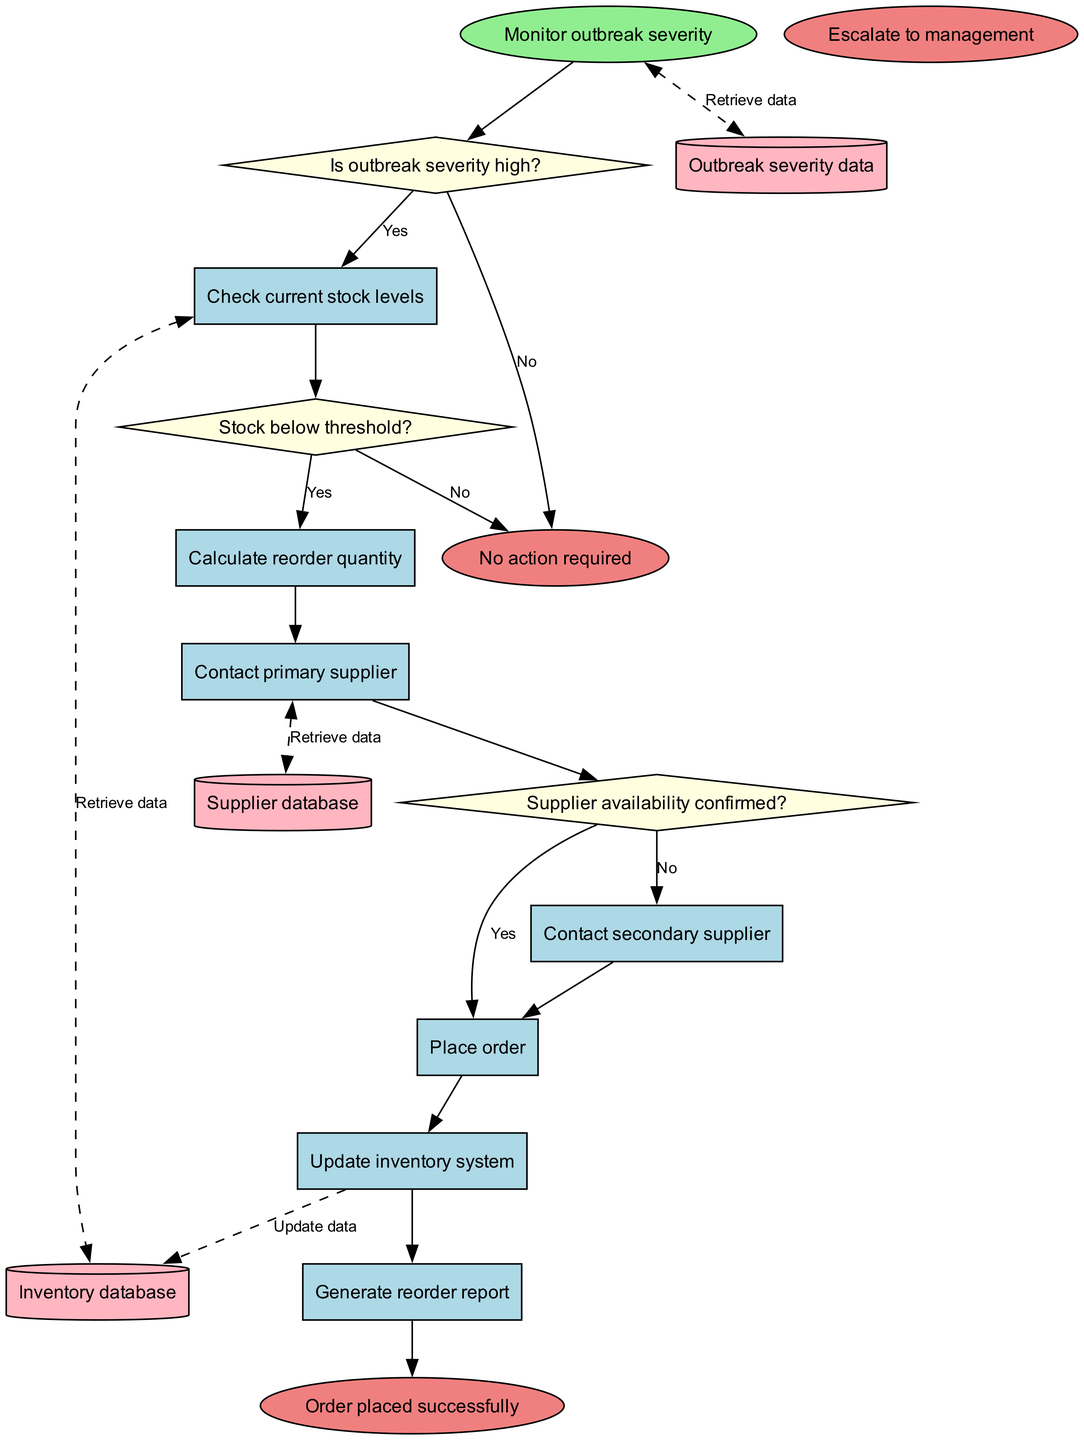What is the starting node of the process? The starting node, which represents the beginning of the flowchart, is labeled "Monitor outbreak severity."
Answer: Monitor outbreak severity How many decision nodes are present in the flowchart? The flowchart contains three decision nodes: "Is outbreak severity high?", "Stock below threshold?", and "Supplier availability confirmed?"
Answer: Three What happens when the outbreak severity is not high? If the outbreak severity is not high, the flowchart indicates that the process goes to the end node labeled "No action required."
Answer: No action required What is the first process that occurs after monitoring the outbreak severity? After monitoring the outbreak severity, the first process that occurs is "Check current stock levels."
Answer: Check current stock levels What do you do if stock is below the threshold and supplier availability is confirmed? If the stock is below the threshold and supplier availability is confirmed, the flowcharts indicates to "Place order."
Answer: Place order What is the consequence of stock being below the threshold but supplier availability not being confirmed? If the stock is below the threshold and supplier availability is not confirmed, the next action in the flowchart is to escalate the situation to management, indicated by the end node "Escalate to management."
Answer: Escalate to management How many processes are defined in this flowchart? The flowchart lists six distinct processes that occur during the automated reordering system operations.
Answer: Six What are the data stores used in the diagram? The flowchart defines three data stores: "Inventory database," "Supplier database," and "Outbreak severity data."
Answer: Inventory database, Supplier database, Outbreak severity data What action is taken after placing an order? After placing an order, the next action in the sequence is to "Update inventory system."
Answer: Update inventory system 